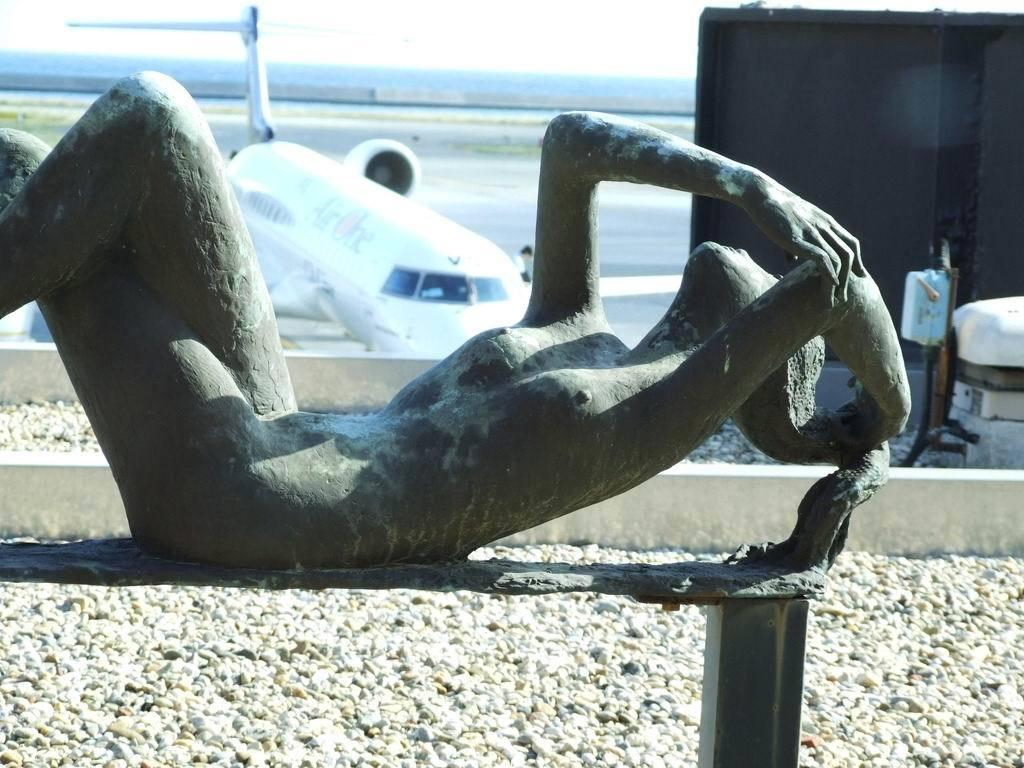What is located on the ground in the image? There is a statue present on the ground in the image. Can you describe anything visible in the distance? There is an airplane visible in the distance. What type of lettuce is being used to make the toys in the image? There is no lettuce or toys present in the image. 